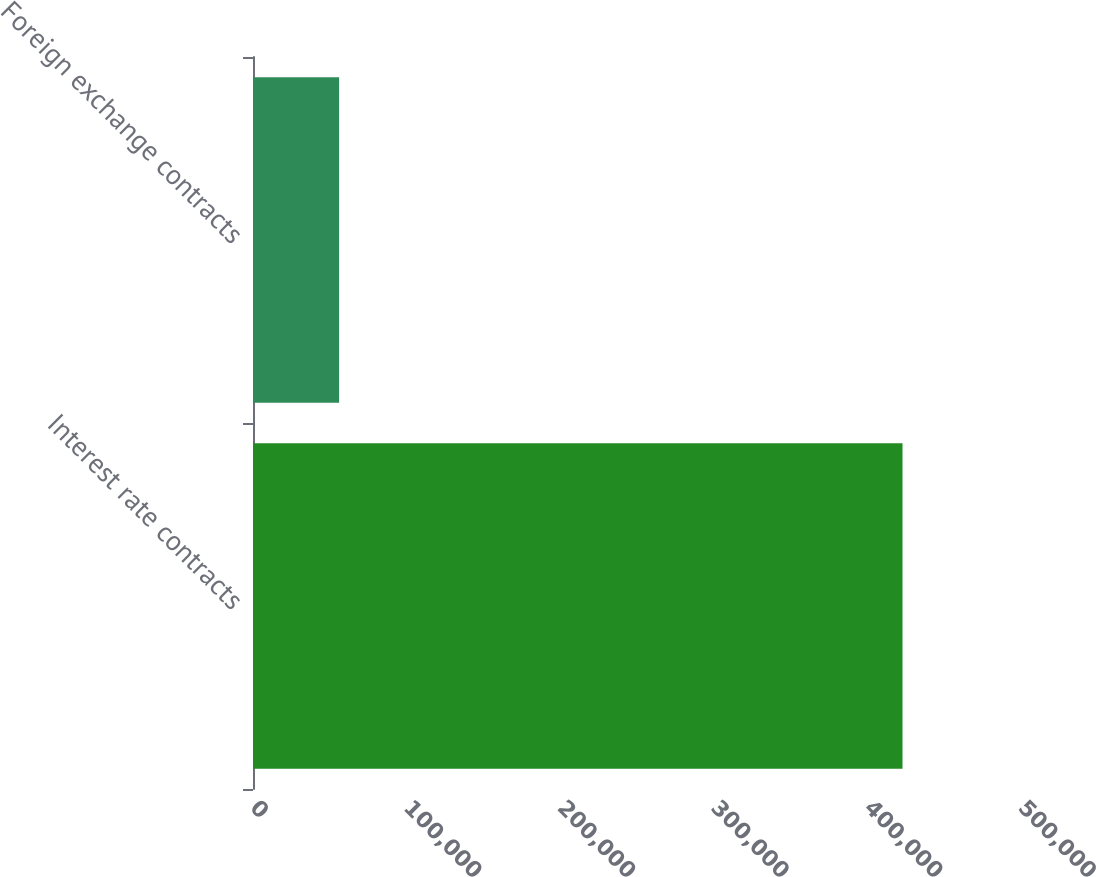<chart> <loc_0><loc_0><loc_500><loc_500><bar_chart><fcel>Interest rate contracts<fcel>Foreign exchange contracts<nl><fcel>422864<fcel>56062<nl></chart> 